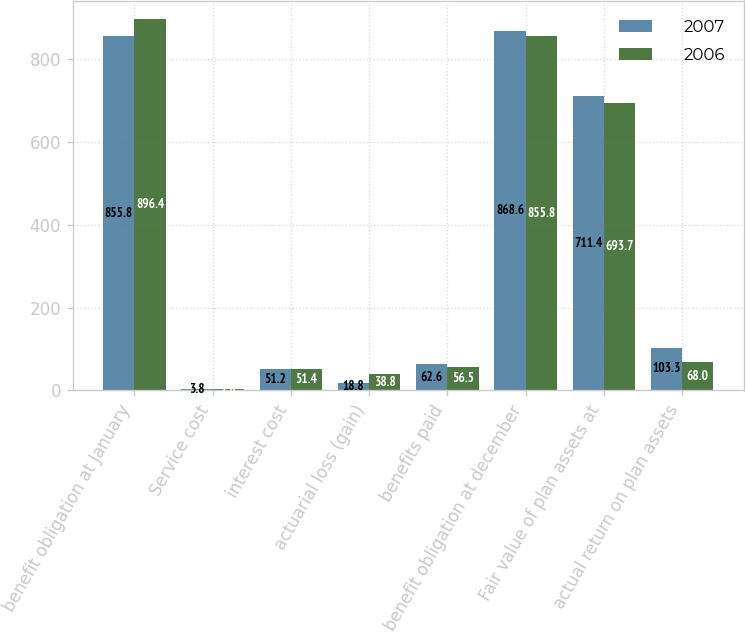Convert chart. <chart><loc_0><loc_0><loc_500><loc_500><stacked_bar_chart><ecel><fcel>benefit obligation at January<fcel>Service cost<fcel>interest cost<fcel>actuarial loss (gain)<fcel>benefits paid<fcel>benefit obligation at december<fcel>Fair value of plan assets at<fcel>actual return on plan assets<nl><fcel>2007<fcel>855.8<fcel>3.8<fcel>51.2<fcel>18.8<fcel>62.6<fcel>868.6<fcel>711.4<fcel>103.3<nl><fcel>2006<fcel>896.4<fcel>2.8<fcel>51.4<fcel>38.8<fcel>56.5<fcel>855.8<fcel>693.7<fcel>68<nl></chart> 